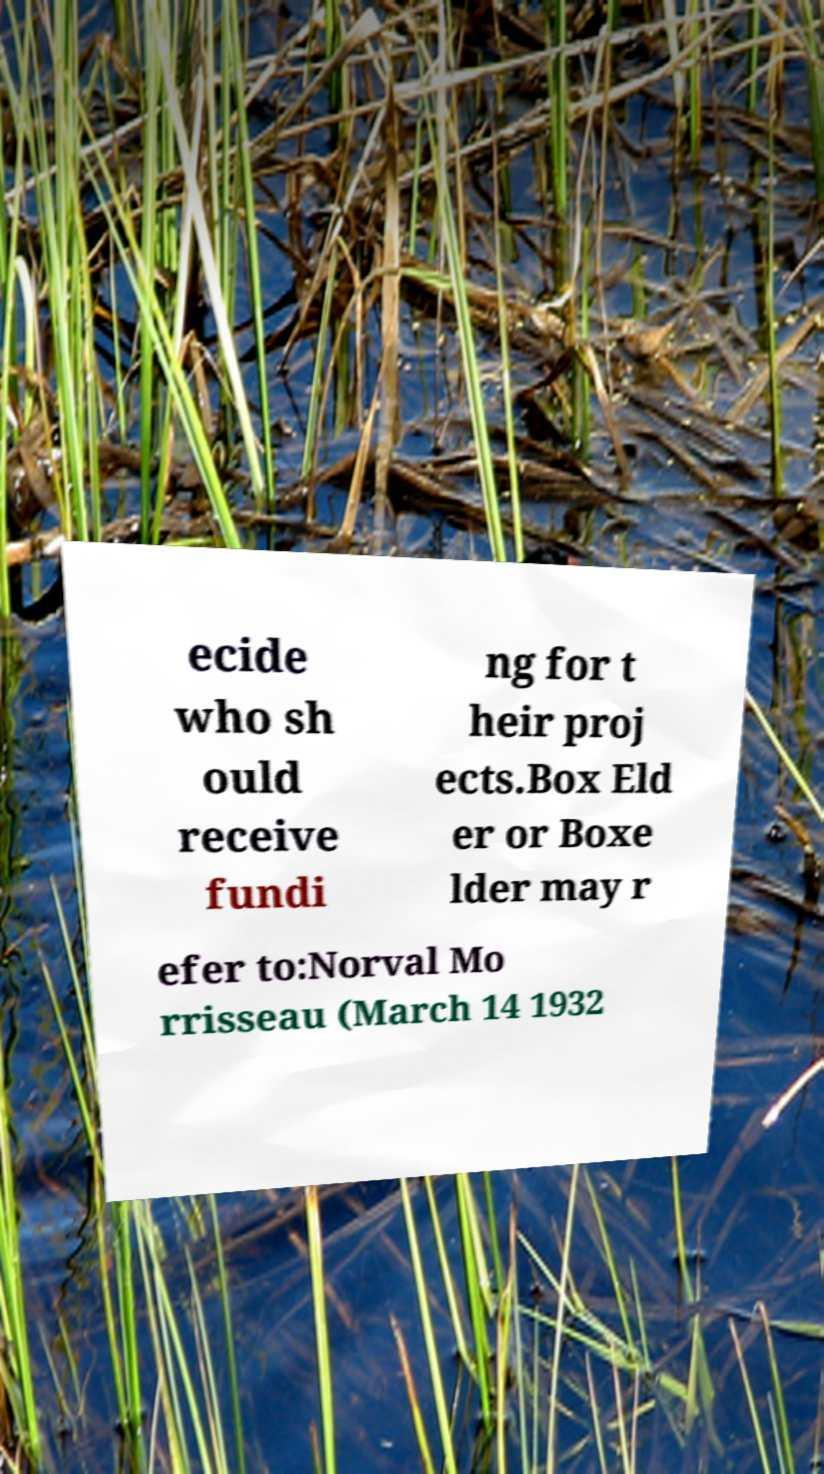There's text embedded in this image that I need extracted. Can you transcribe it verbatim? ecide who sh ould receive fundi ng for t heir proj ects.Box Eld er or Boxe lder may r efer to:Norval Mo rrisseau (March 14 1932 